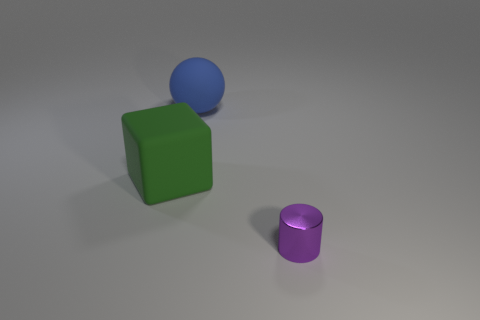Add 1 small purple blocks. How many objects exist? 4 Subtract all cubes. How many objects are left? 2 Add 1 brown shiny spheres. How many brown shiny spheres exist? 1 Subtract 0 green balls. How many objects are left? 3 Subtract all small blue matte spheres. Subtract all tiny cylinders. How many objects are left? 2 Add 2 big matte spheres. How many big matte spheres are left? 3 